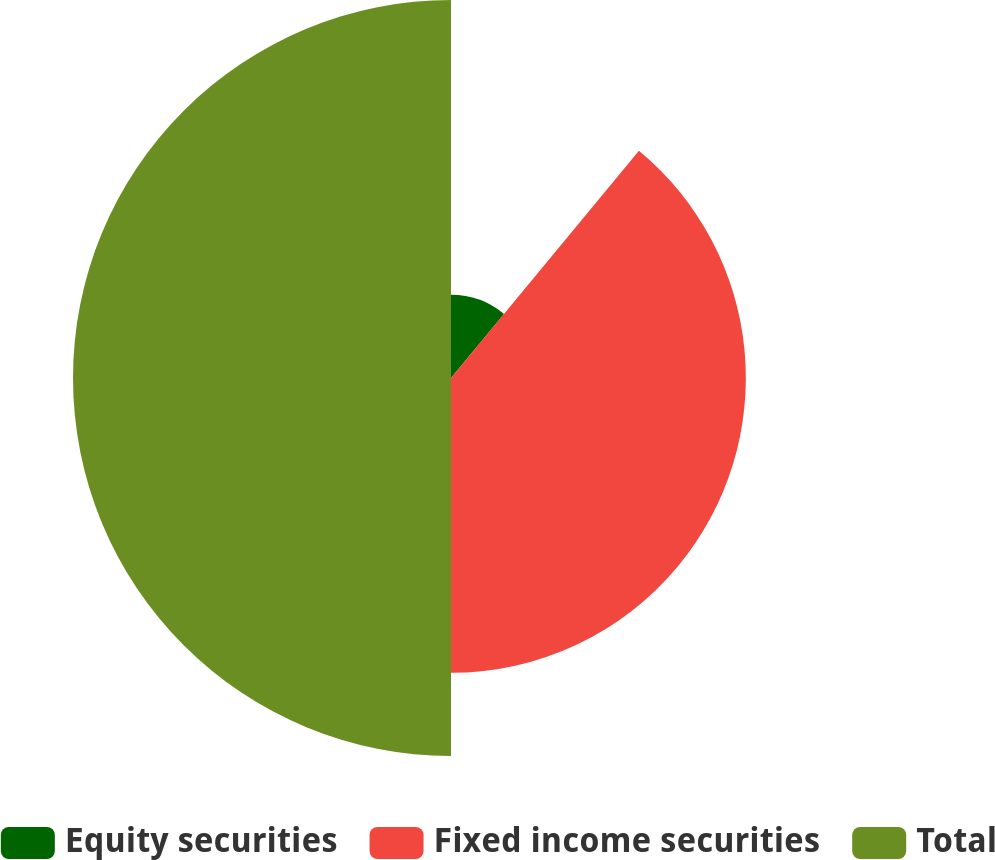<chart> <loc_0><loc_0><loc_500><loc_500><pie_chart><fcel>Equity securities<fcel>Fixed income securities<fcel>Total<nl><fcel>11.0%<fcel>39.0%<fcel>50.0%<nl></chart> 